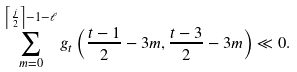<formula> <loc_0><loc_0><loc_500><loc_500>\sum _ { m = 0 } ^ { \left \lceil \frac { j } { 2 } \right \rceil - 1 - \ell } g _ { t } \left ( \frac { t - 1 } { 2 } - 3 m , \frac { t - 3 } { 2 } - 3 m \right ) \ll 0 .</formula> 